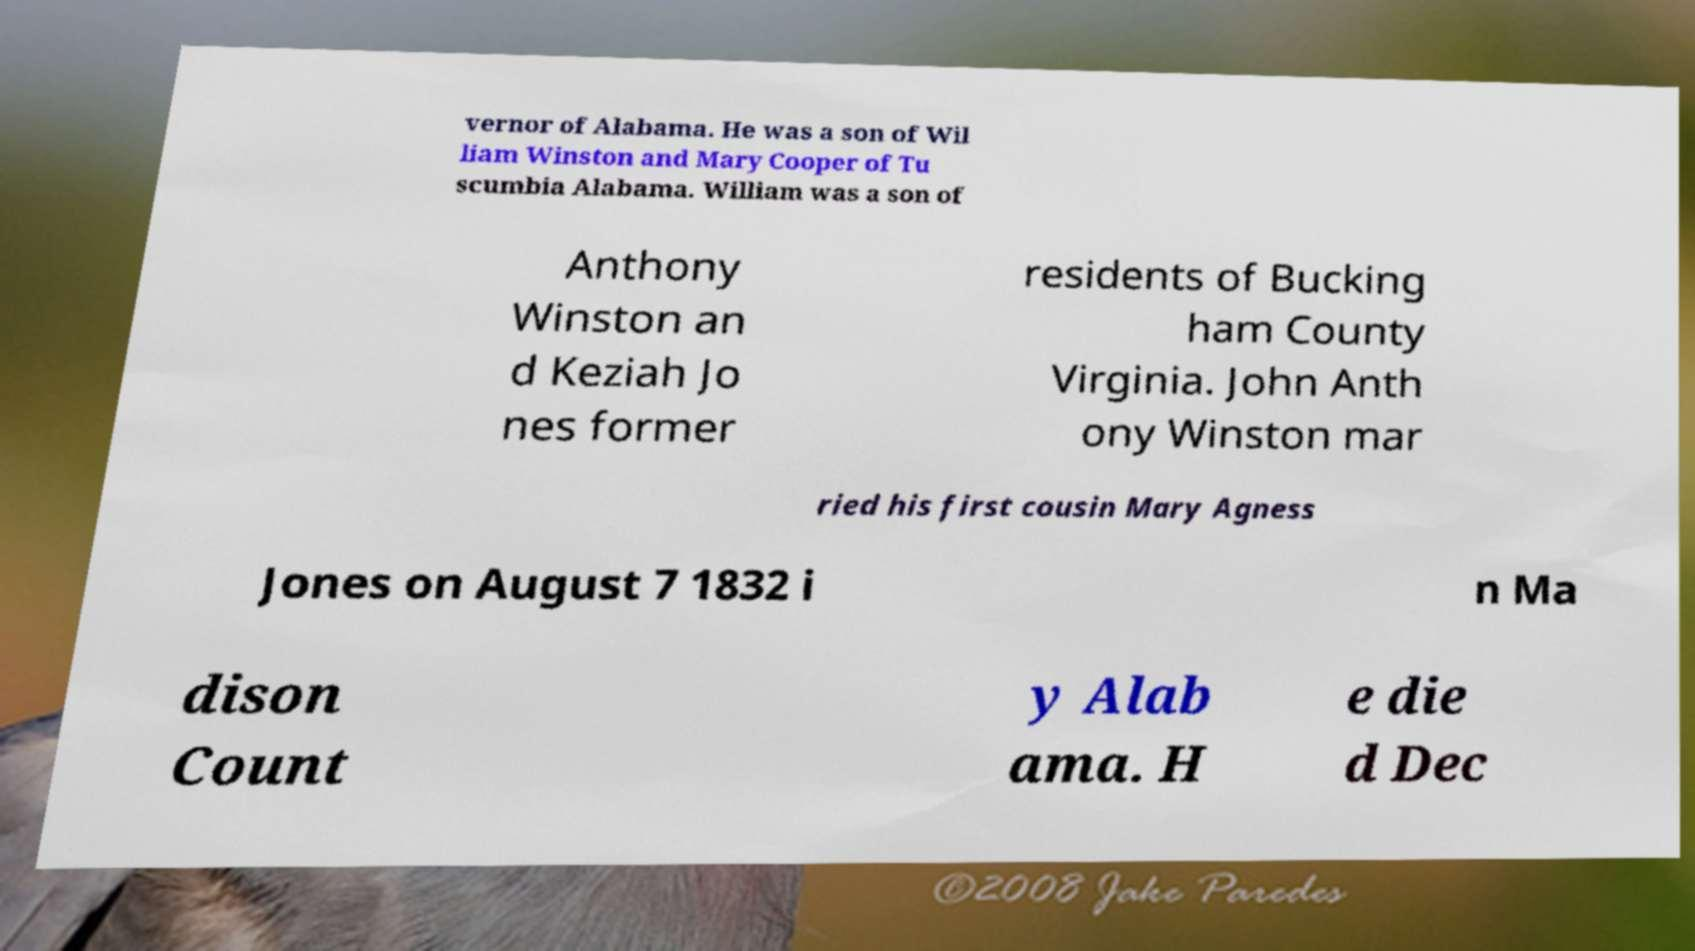Can you accurately transcribe the text from the provided image for me? vernor of Alabama. He was a son of Wil liam Winston and Mary Cooper of Tu scumbia Alabama. William was a son of Anthony Winston an d Keziah Jo nes former residents of Bucking ham County Virginia. John Anth ony Winston mar ried his first cousin Mary Agness Jones on August 7 1832 i n Ma dison Count y Alab ama. H e die d Dec 